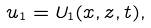Convert formula to latex. <formula><loc_0><loc_0><loc_500><loc_500>u _ { 1 } = U _ { 1 } ( x , z , t ) ,</formula> 